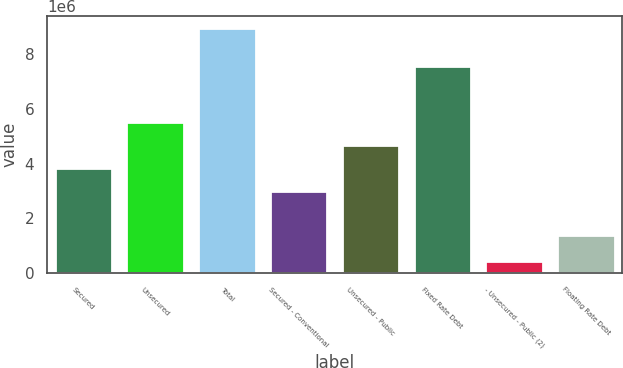Convert chart to OTSL. <chart><loc_0><loc_0><loc_500><loc_500><bar_chart><fcel>Secured<fcel>Unsecured<fcel>Total<fcel>Secured - Conventional<fcel>Unsecured - Public<fcel>Fixed Rate Debt<fcel>- Unsecured - Public (2)<fcel>Floating Rate Debt<nl><fcel>3.83333e+06<fcel>5.5353e+06<fcel>8.95729e+06<fcel>2.98234e+06<fcel>4.68431e+06<fcel>7.57372e+06<fcel>447439<fcel>1.38357e+06<nl></chart> 